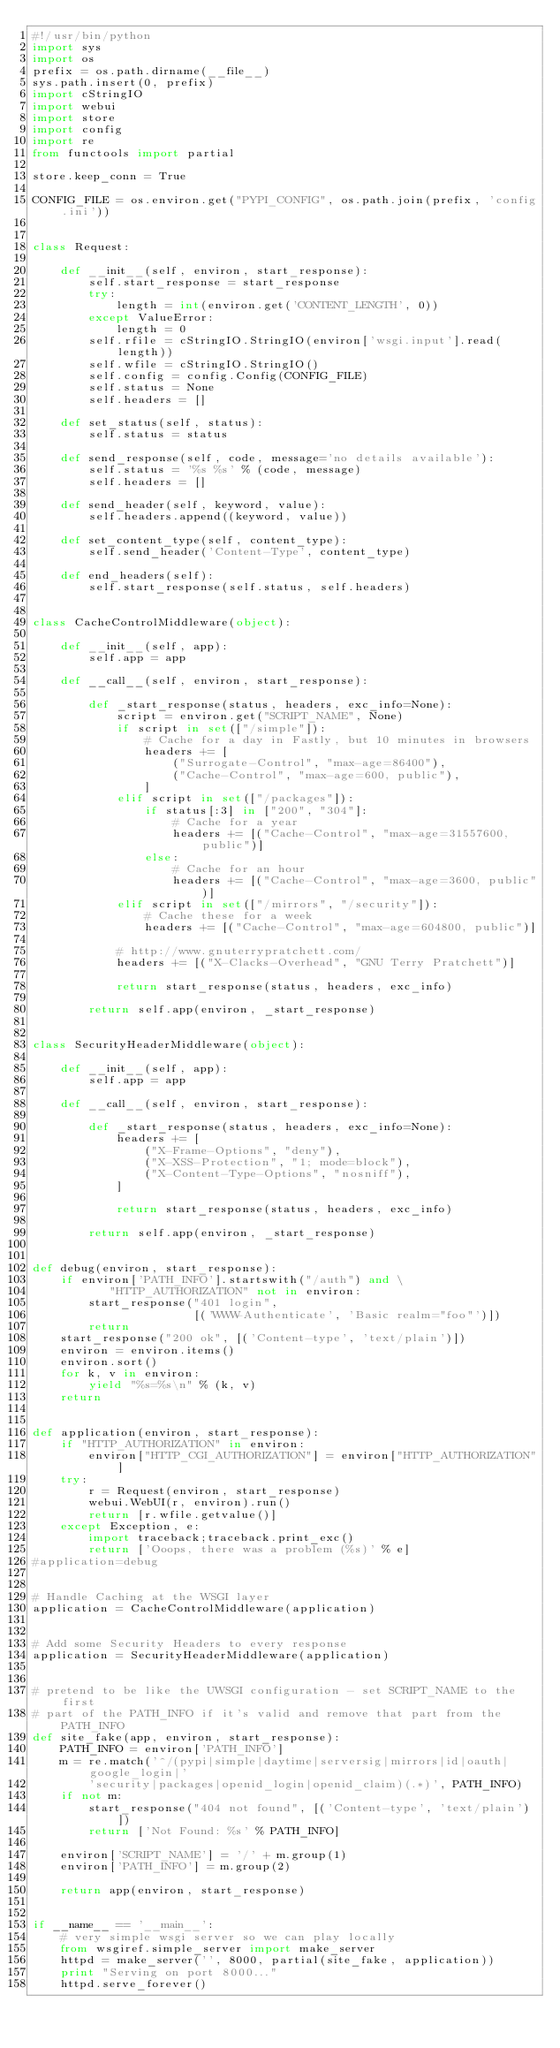<code> <loc_0><loc_0><loc_500><loc_500><_Python_>#!/usr/bin/python
import sys
import os
prefix = os.path.dirname(__file__)
sys.path.insert(0, prefix)
import cStringIO
import webui
import store
import config
import re
from functools import partial

store.keep_conn = True

CONFIG_FILE = os.environ.get("PYPI_CONFIG", os.path.join(prefix, 'config.ini'))


class Request:

    def __init__(self, environ, start_response):
        self.start_response = start_response
        try:
            length = int(environ.get('CONTENT_LENGTH', 0))
        except ValueError:
            length = 0
        self.rfile = cStringIO.StringIO(environ['wsgi.input'].read(length))
        self.wfile = cStringIO.StringIO()
        self.config = config.Config(CONFIG_FILE)
        self.status = None
        self.headers = []

    def set_status(self, status):
        self.status = status

    def send_response(self, code, message='no details available'):
        self.status = '%s %s' % (code, message)
        self.headers = []

    def send_header(self, keyword, value):
        self.headers.append((keyword, value))

    def set_content_type(self, content_type):
        self.send_header('Content-Type', content_type)

    def end_headers(self):
        self.start_response(self.status, self.headers)


class CacheControlMiddleware(object):

    def __init__(self, app):
        self.app = app

    def __call__(self, environ, start_response):

        def _start_response(status, headers, exc_info=None):
            script = environ.get("SCRIPT_NAME", None)
            if script in set(["/simple"]):
                # Cache for a day in Fastly, but 10 minutes in browsers
                headers += [
                    ("Surrogate-Control", "max-age=86400"),
                    ("Cache-Control", "max-age=600, public"),
                ]
            elif script in set(["/packages"]):
                if status[:3] in ["200", "304"]:
                    # Cache for a year
                    headers += [("Cache-Control", "max-age=31557600, public")]
                else:
                    # Cache for an hour
                    headers += [("Cache-Control", "max-age=3600, public")]
            elif script in set(["/mirrors", "/security"]):
                # Cache these for a week
                headers += [("Cache-Control", "max-age=604800, public")]

            # http://www.gnuterrypratchett.com/
            headers += [("X-Clacks-Overhead", "GNU Terry Pratchett")]

            return start_response(status, headers, exc_info)

        return self.app(environ, _start_response)


class SecurityHeaderMiddleware(object):

    def __init__(self, app):
        self.app = app

    def __call__(self, environ, start_response):

        def _start_response(status, headers, exc_info=None):
            headers += [
                ("X-Frame-Options", "deny"),
                ("X-XSS-Protection", "1; mode=block"),
                ("X-Content-Type-Options", "nosniff"),
            ]

            return start_response(status, headers, exc_info)

        return self.app(environ, _start_response)


def debug(environ, start_response):
    if environ['PATH_INFO'].startswith("/auth") and \
           "HTTP_AUTHORIZATION" not in environ:
        start_response("401 login",
                       [('WWW-Authenticate', 'Basic realm="foo"')])
        return
    start_response("200 ok", [('Content-type', 'text/plain')])
    environ = environ.items()
    environ.sort()
    for k, v in environ:
        yield "%s=%s\n" % (k, v)
    return


def application(environ, start_response):
    if "HTTP_AUTHORIZATION" in environ:
        environ["HTTP_CGI_AUTHORIZATION"] = environ["HTTP_AUTHORIZATION"]
    try:
        r = Request(environ, start_response)
        webui.WebUI(r, environ).run()
        return [r.wfile.getvalue()]
    except Exception, e:
        import traceback;traceback.print_exc()
        return ['Ooops, there was a problem (%s)' % e]
#application=debug


# Handle Caching at the WSGI layer
application = CacheControlMiddleware(application)


# Add some Security Headers to every response
application = SecurityHeaderMiddleware(application)


# pretend to be like the UWSGI configuration - set SCRIPT_NAME to the first
# part of the PATH_INFO if it's valid and remove that part from the PATH_INFO
def site_fake(app, environ, start_response):
    PATH_INFO = environ['PATH_INFO']
    m = re.match('^/(pypi|simple|daytime|serversig|mirrors|id|oauth|google_login|'
        'security|packages|openid_login|openid_claim)(.*)', PATH_INFO)
    if not m:
        start_response("404 not found", [('Content-type', 'text/plain')])
        return ['Not Found: %s' % PATH_INFO]

    environ['SCRIPT_NAME'] = '/' + m.group(1)
    environ['PATH_INFO'] = m.group(2)

    return app(environ, start_response)


if __name__ == '__main__':
    # very simple wsgi server so we can play locally
    from wsgiref.simple_server import make_server
    httpd = make_server('', 8000, partial(site_fake, application))
    print "Serving on port 8000..."
    httpd.serve_forever()
</code> 